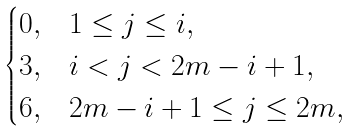<formula> <loc_0><loc_0><loc_500><loc_500>\begin{cases} 0 , & 1 \leq j \leq i , \\ 3 , & i < j < 2 m - i + 1 , \\ 6 , & 2 m - i + 1 \leq j \leq 2 m , \end{cases}</formula> 